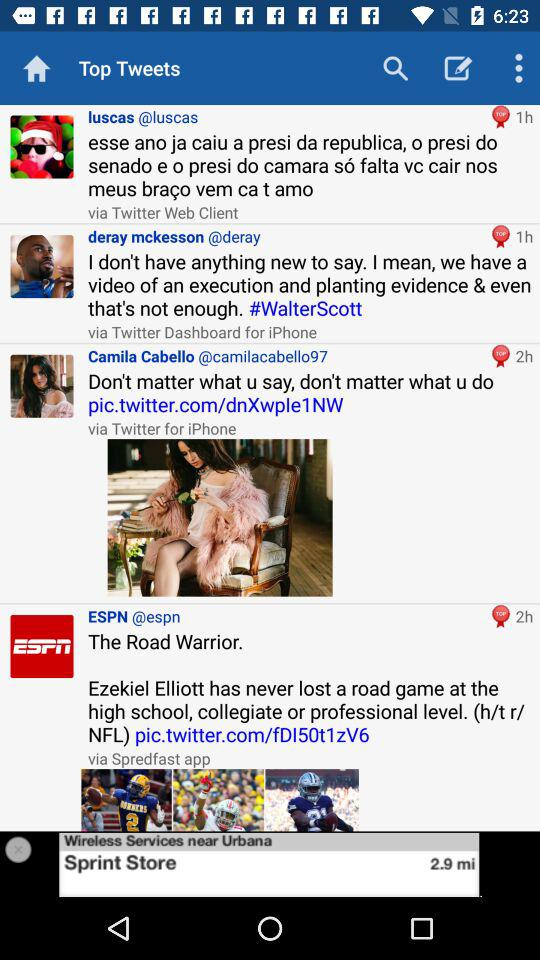What is the twitter username of deray mckesson? The username is "deray". 